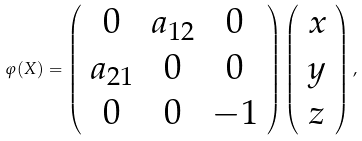Convert formula to latex. <formula><loc_0><loc_0><loc_500><loc_500>\varphi ( X ) = \left ( \begin{array} { c c c } 0 & a _ { 1 2 } & 0 \\ a _ { 2 1 } & 0 & 0 \\ 0 & 0 & - 1 \end{array} \right ) \left ( \begin{array} { c c c } x \\ y \\ z \end{array} \right ) ,</formula> 